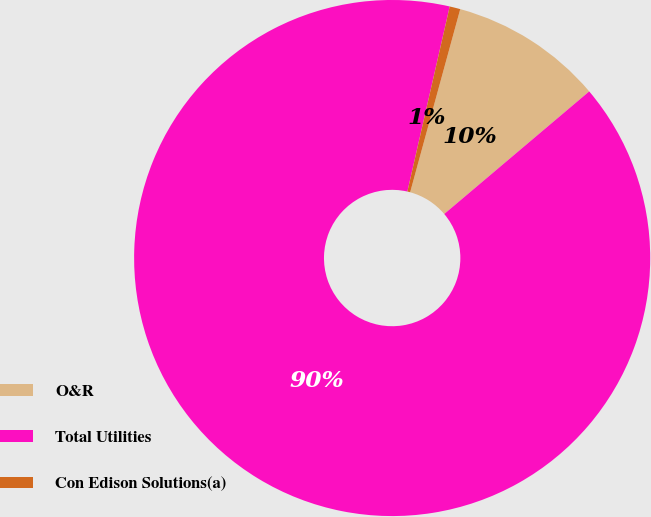Convert chart to OTSL. <chart><loc_0><loc_0><loc_500><loc_500><pie_chart><fcel>O&R<fcel>Total Utilities<fcel>Con Edison Solutions(a)<nl><fcel>9.58%<fcel>89.75%<fcel>0.67%<nl></chart> 